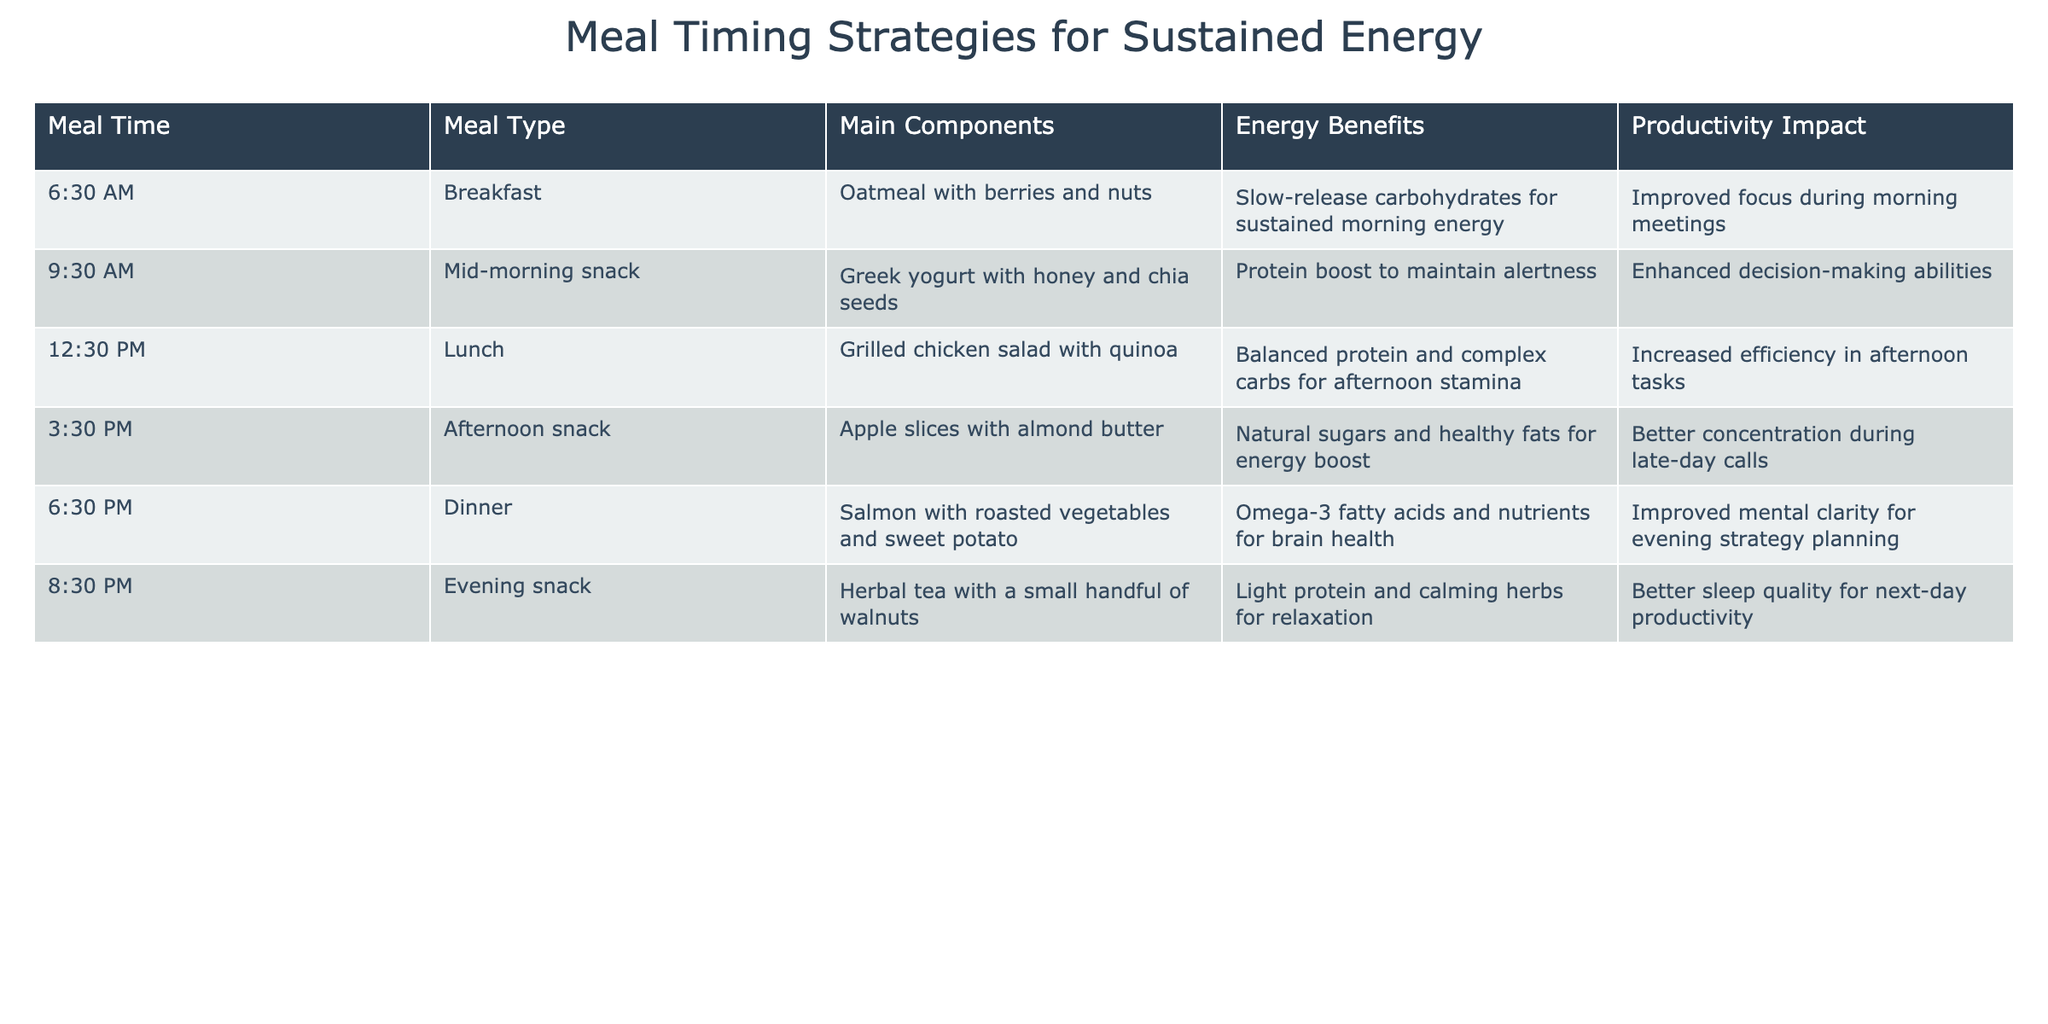What time is lunch served? The table indicates that lunch is served at 12:30 PM.
Answer: 12:30 PM What is the main component of the afternoon snack? According to the table, the afternoon snack consists of apple slices with almond butter.
Answer: Apple slices with almond butter Which meal type includes omega-3 fatty acids? The dinner meal type, which features salmon with roasted vegetables and sweet potato, provides omega-3 fatty acids.
Answer: Dinner Do all meal types mentioned provide energy benefits? Yes, according to the table, each meal type listed has associated energy benefits.
Answer: Yes Which meal provides a protein boost to maintain alertness? The mid-morning snack, which includes Greek yogurt with honey and chia seeds, provides a protein boost for alertness.
Answer: Mid-morning snack What are the energy benefits associated with breakfast? The energy benefits of breakfast include slow-release carbohydrates for sustained morning energy.
Answer: Slow-release carbohydrates for sustained morning energy Which meal has the highest concentration of important nutrients for brain health? The dinner meal featuring salmon offers a high concentration of omega-3 fatty acids and nutrients for brain health.
Answer: Dinner Which meal is designed to improve focus during morning meetings? Breakfast, consisting of oatmeal with berries and nuts, is designed to improve focus during morning meetings.
Answer: Breakfast If a person skips breakfast, which meal might significantly impact their focus later in the day? Skipping breakfast might significantly affect focus later, particularly during morning meetings, thus negatively impacting productivity afterward.
Answer: Morning meetings What are the potential productivity impacts of an evening snack? The evening snack can improve sleep quality, leading to better productivity the following day.
Answer: Better sleep quality for next-day productivity How many meals contain healthy fats? Both the afternoon snack (apple slices with almond butter) and dinner (salmon) contain healthy fats. Thus, there are two meals that provide healthy fats.
Answer: Two meals 